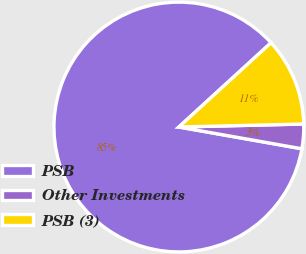<chart> <loc_0><loc_0><loc_500><loc_500><pie_chart><fcel>PSB<fcel>Other Investments<fcel>PSB (3)<nl><fcel>85.43%<fcel>3.17%<fcel>11.4%<nl></chart> 